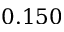Convert formula to latex. <formula><loc_0><loc_0><loc_500><loc_500>0 . 1 5 0</formula> 